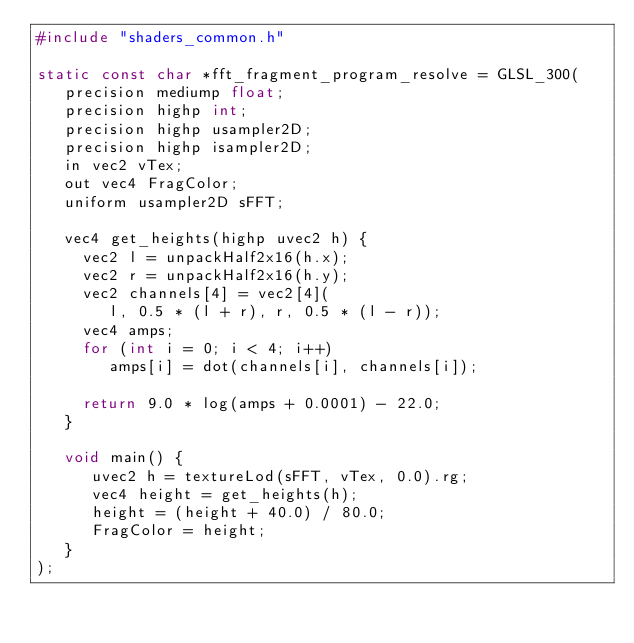Convert code to text. <code><loc_0><loc_0><loc_500><loc_500><_C_>#include "shaders_common.h"

static const char *fft_fragment_program_resolve = GLSL_300(
   precision mediump float;
   precision highp int;
   precision highp usampler2D;
   precision highp isampler2D;
   in vec2 vTex;
   out vec4 FragColor;
   uniform usampler2D sFFT;

   vec4 get_heights(highp uvec2 h) {
     vec2 l = unpackHalf2x16(h.x);
     vec2 r = unpackHalf2x16(h.y);
     vec2 channels[4] = vec2[4](
        l, 0.5 * (l + r), r, 0.5 * (l - r));
     vec4 amps;
     for (int i = 0; i < 4; i++)
        amps[i] = dot(channels[i], channels[i]);

     return 9.0 * log(amps + 0.0001) - 22.0;
   }

   void main() {
      uvec2 h = textureLod(sFFT, vTex, 0.0).rg;
      vec4 height = get_heights(h);
      height = (height + 40.0) / 80.0;
      FragColor = height;
   }
);
</code> 